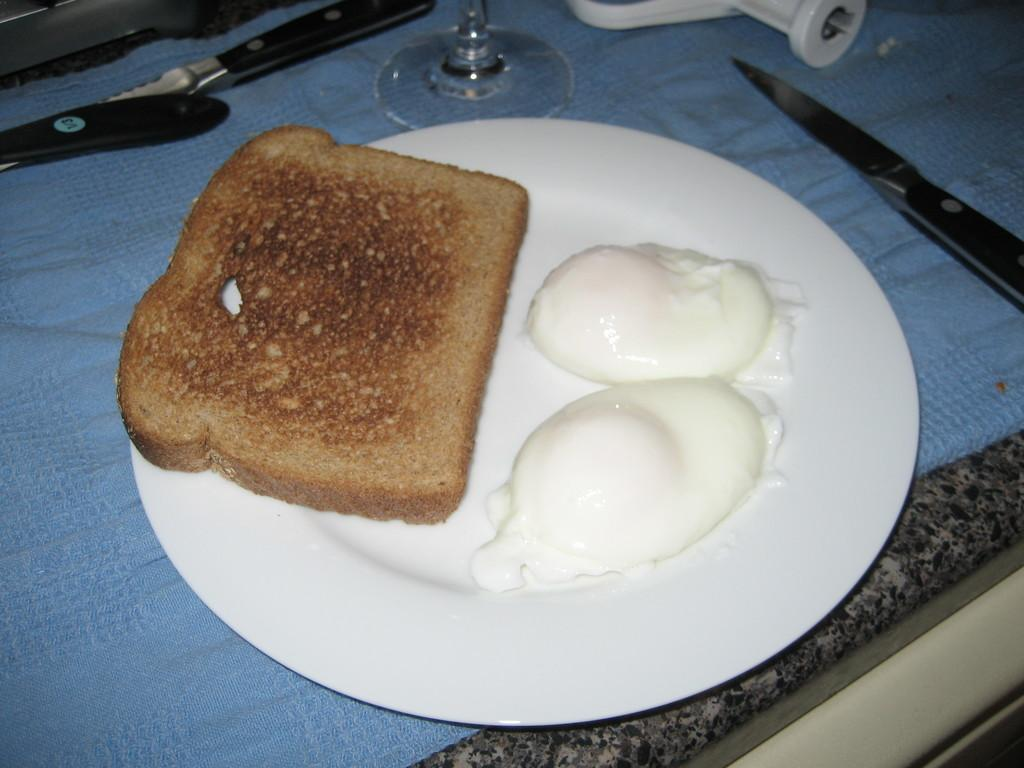What piece of furniture is present in the image? There is a table in the image. What utensil can be seen on the table? There is a knife on the table. What type of dishware is on the table? There is a white plate on the table. What type of food is on the table? There is bread on the table. What condiment is on the table? There is cream on the table. What type of glassware is on the table? There is a wine glass on the table. What type of material is covering the table? There is a cloth on the table. What can be seen in the top left corner of the image? There is a window in the top left corner of the image. How many balls are visible on the table in the image? There are no balls present on the table in the image. What type of industry can be seen through the window in the image? There is no industry visible through the window in the image; only a window is present in the top left corner. 